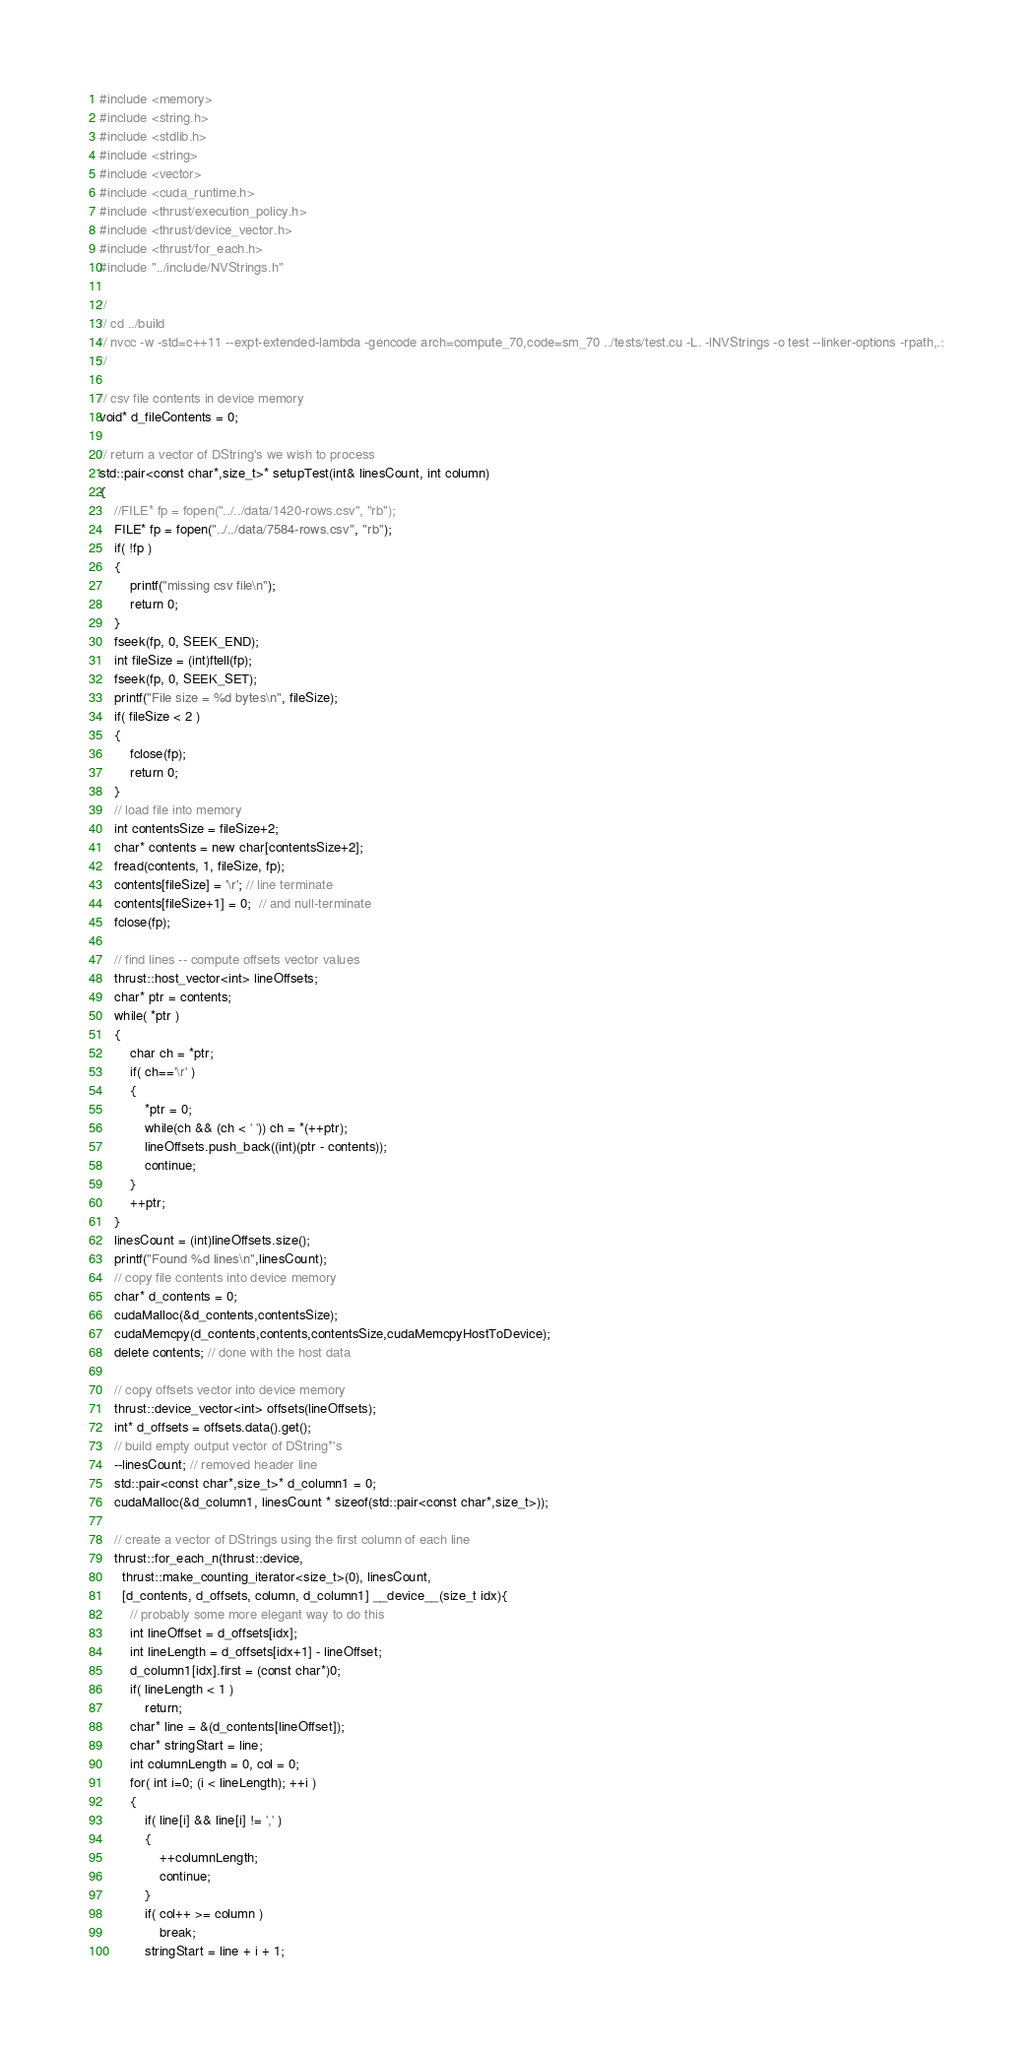<code> <loc_0><loc_0><loc_500><loc_500><_Cuda_>#include <memory>
#include <string.h>
#include <stdlib.h>
#include <string>
#include <vector>
#include <cuda_runtime.h>
#include <thrust/execution_policy.h>
#include <thrust/device_vector.h>
#include <thrust/for_each.h>
#include "../include/NVStrings.h"

//
// cd ../build
// nvcc -w -std=c++11 --expt-extended-lambda -gencode arch=compute_70,code=sm_70 ../tests/test.cu -L. -lNVStrings -o test --linker-options -rpath,.:
//

// csv file contents in device memory
void* d_fileContents = 0;

// return a vector of DString's we wish to process
std::pair<const char*,size_t>* setupTest(int& linesCount, int column)
{
    //FILE* fp = fopen("../../data/1420-rows.csv", "rb");
    FILE* fp = fopen("../../data/7584-rows.csv", "rb");
    if( !fp )
    {
        printf("missing csv file\n");
        return 0;
    }
	fseek(fp, 0, SEEK_END);
	int fileSize = (int)ftell(fp);
    fseek(fp, 0, SEEK_SET);
    printf("File size = %d bytes\n", fileSize);
    if( fileSize < 2 )
    {
        fclose(fp);
        return 0;
    }
    // load file into memory
    int contentsSize = fileSize+2;
    char* contents = new char[contentsSize+2];
    fread(contents, 1, fileSize, fp);
    contents[fileSize] = '\r'; // line terminate
	contents[fileSize+1] = 0;  // and null-terminate
	fclose(fp);

    // find lines -- compute offsets vector values
    thrust::host_vector<int> lineOffsets;
    char* ptr = contents;
    while( *ptr )
    {
        char ch = *ptr;
        if( ch=='\r' )
        {
            *ptr = 0;
            while(ch && (ch < ' ')) ch = *(++ptr);
            lineOffsets.push_back((int)(ptr - contents));
            continue;
        }    
        ++ptr;
    }
    linesCount = (int)lineOffsets.size();
    printf("Found %d lines\n",linesCount);
    // copy file contents into device memory
    char* d_contents = 0;
    cudaMalloc(&d_contents,contentsSize);
    cudaMemcpy(d_contents,contents,contentsSize,cudaMemcpyHostToDevice);
    delete contents; // done with the host data

    // copy offsets vector into device memory
    thrust::device_vector<int> offsets(lineOffsets);
    int* d_offsets = offsets.data().get();
    // build empty output vector of DString*'s
    --linesCount; // removed header line
    std::pair<const char*,size_t>* d_column1 = 0;
    cudaMalloc(&d_column1, linesCount * sizeof(std::pair<const char*,size_t>));

    // create a vector of DStrings using the first column of each line
    thrust::for_each_n(thrust::device,
      thrust::make_counting_iterator<size_t>(0), linesCount, 
      [d_contents, d_offsets, column, d_column1] __device__(size_t idx){
        // probably some more elegant way to do this
        int lineOffset = d_offsets[idx];
        int lineLength = d_offsets[idx+1] - lineOffset;
        d_column1[idx].first = (const char*)0;
        if( lineLength < 1 )
            return;
        char* line = &(d_contents[lineOffset]);
        char* stringStart = line;
        int columnLength = 0, col = 0;
        for( int i=0; (i < lineLength); ++i )
        {
            if( line[i] && line[i] != ',' )
            {
                ++columnLength;
                continue;
            }
            if( col++ >= column )
                break;
            stringStart = line + i + 1;</code> 